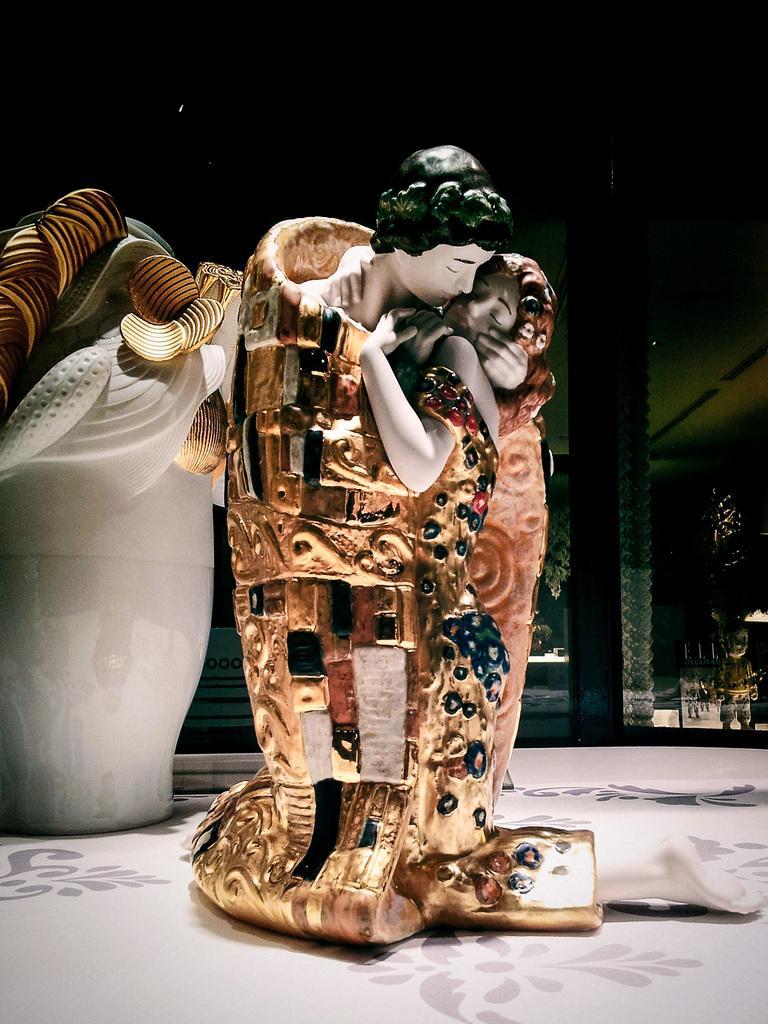Can you describe this image briefly? In this image I can see there are two different sculptures kept on the floor and I can see a beam on the right side. 